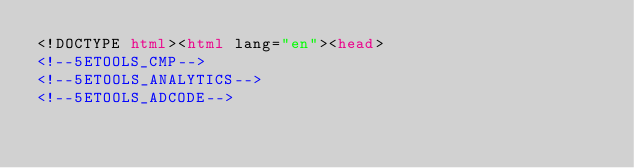<code> <loc_0><loc_0><loc_500><loc_500><_HTML_><!DOCTYPE html><html lang="en"><head>
<!--5ETOOLS_CMP-->
<!--5ETOOLS_ANALYTICS-->
<!--5ETOOLS_ADCODE--></code> 